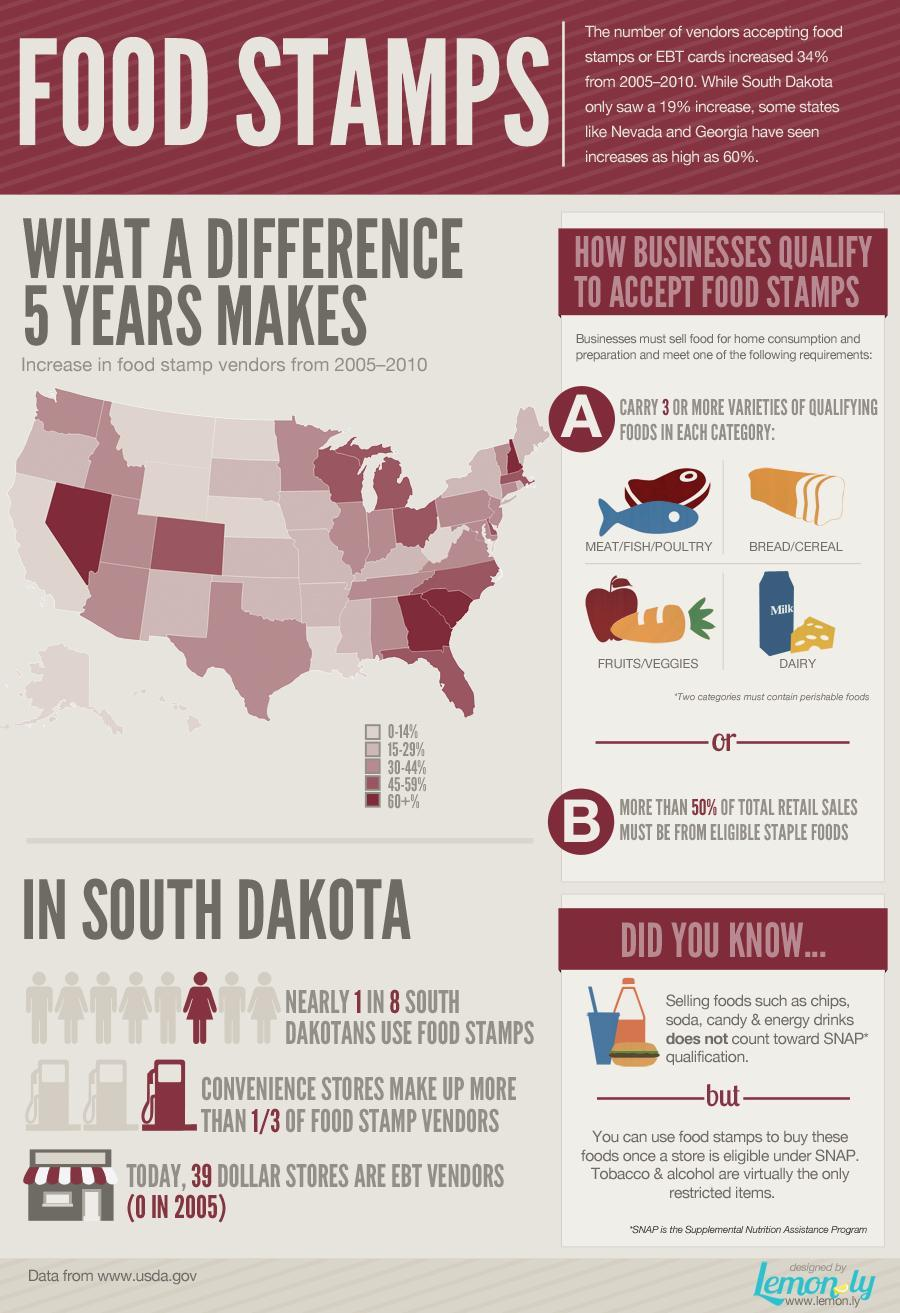How many conditions are there for a business to qualify to accept food stamps?
Answer the question with a short phrase. 1 